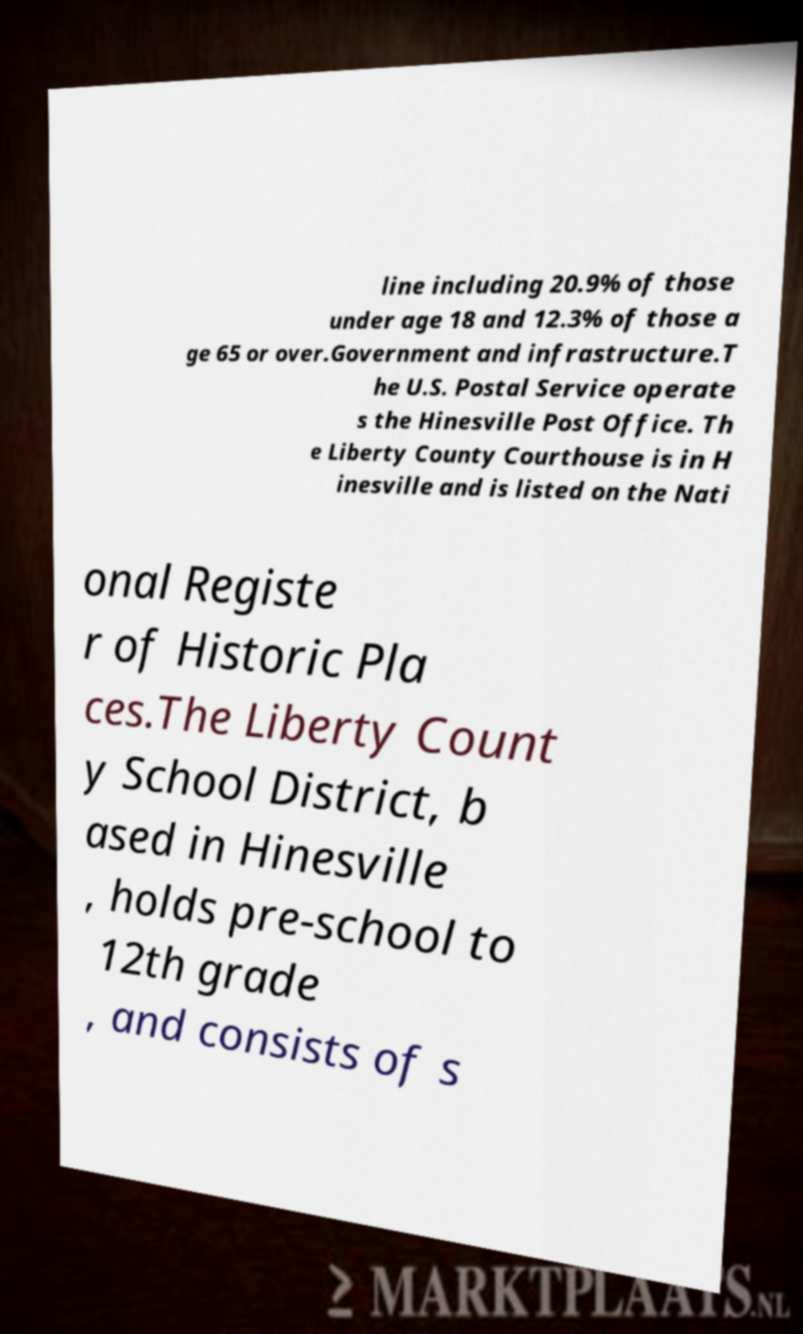I need the written content from this picture converted into text. Can you do that? line including 20.9% of those under age 18 and 12.3% of those a ge 65 or over.Government and infrastructure.T he U.S. Postal Service operate s the Hinesville Post Office. Th e Liberty County Courthouse is in H inesville and is listed on the Nati onal Registe r of Historic Pla ces.The Liberty Count y School District, b ased in Hinesville , holds pre-school to 12th grade , and consists of s 